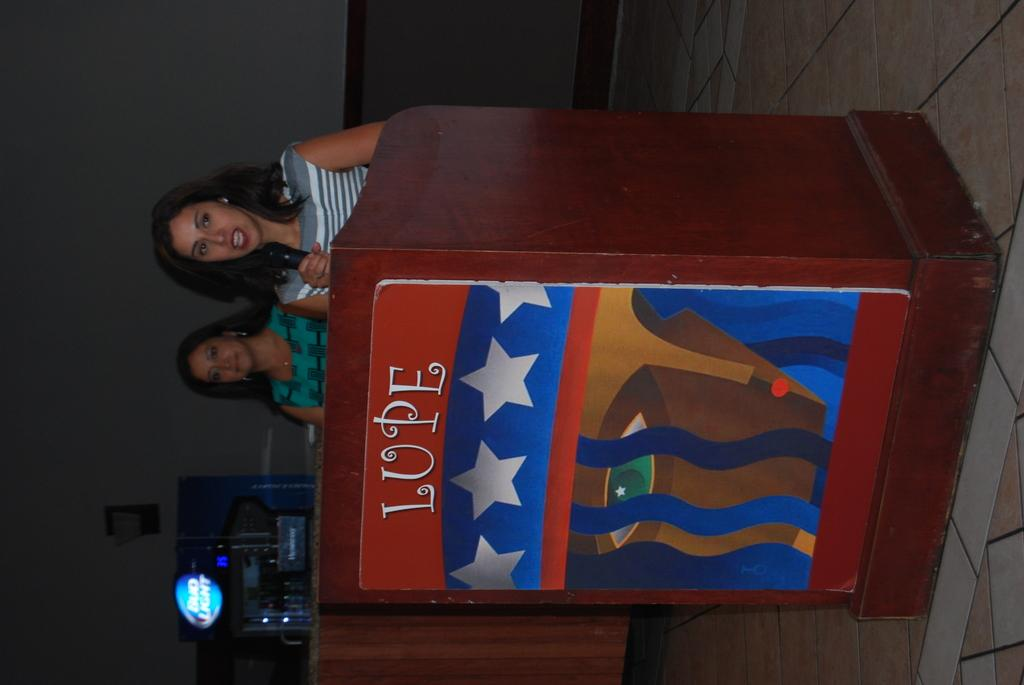How many women are in the image? There are two women in the image. What is one of the women holding in her hand? One of the women is holding a mic in her hand. What is in front of the women in the image? There is a podium in front of the women. What can be seen in the background of the image? The background of the image includes a wall and a machine. What type of class are the fairies attending in the image? There are no fairies present in the image, and therefore no class can be observed. How many horses are visible in the image? There are no horses present in the image. 